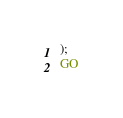<code> <loc_0><loc_0><loc_500><loc_500><_SQL_>);
GO
</code> 